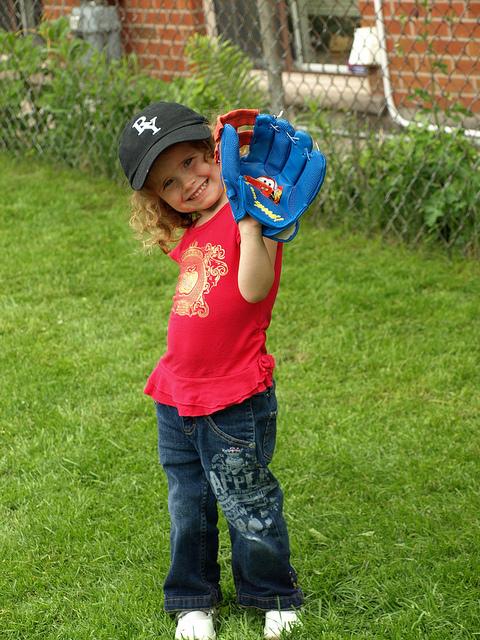What is the girl holding?
Answer briefly. Baseball glove. What is on the child's head?
Concise answer only. Hat. What is show on the child's glove?
Keep it brief. Lightning mcqueen. Is the child old enough to drive a car?
Concise answer only. No. 